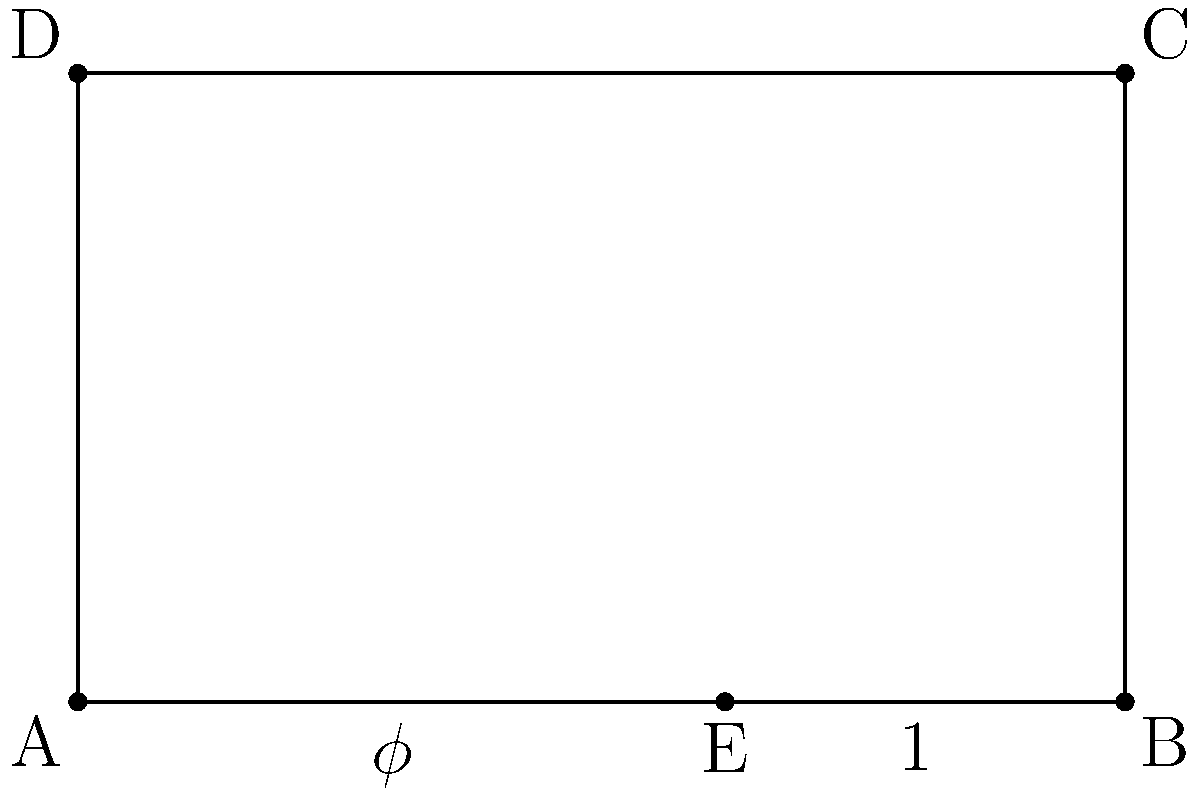In the composition of a musical piece, you decide to use the golden ratio to determine the structure. The rectangle ABCD represents the entire piece, with length 5 units and height 3 units. Point E divides AB according to the golden ratio. If the coordinates of A are (0,0) and B are (5,0), what are the coordinates of E? To find the coordinates of E, we need to follow these steps:

1) The golden ratio, denoted by $\phi$, is approximately equal to 1.618033988749895.

2) In a line segment divided by the golden ratio, the ratio of the longer part to the shorter part is equal to $\phi$.

3) Let x be the distance of E from A. Then:
   $\frac{5-x}{x} = \phi$

4) We can write this as an equation:
   $\frac{5-x}{x} = \phi$
   $5-x = \phi x$
   $5 = \phi x + x = x(\phi + 1)$

5) Solving for x:
   $x = \frac{5}{\phi + 1}$

6) We know that $\phi^2 = \phi + 1$, so:
   $x = \frac{5}{\phi + 1} = \frac{5}{\phi^2} = \frac{5}{\phi} \cdot \frac{1}{\phi}$

7) $\frac{1}{\phi} \approx 0.618033988749895$

8) Therefore, $x \approx 5 \cdot 0.618033988749895 \approx 3.09016994374947$

9) The y-coordinate of E is 0, as E lies on the x-axis.

Thus, the coordinates of E are approximately (3.09, 0).
Answer: (3.09, 0) 